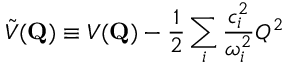Convert formula to latex. <formula><loc_0><loc_0><loc_500><loc_500>\tilde { V } ( { Q } ) \equiv V ( { Q } ) - \frac { 1 } { 2 } \sum _ { i } \frac { c _ { i } ^ { 2 } } { \omega _ { i } ^ { 2 } } Q ^ { 2 }</formula> 